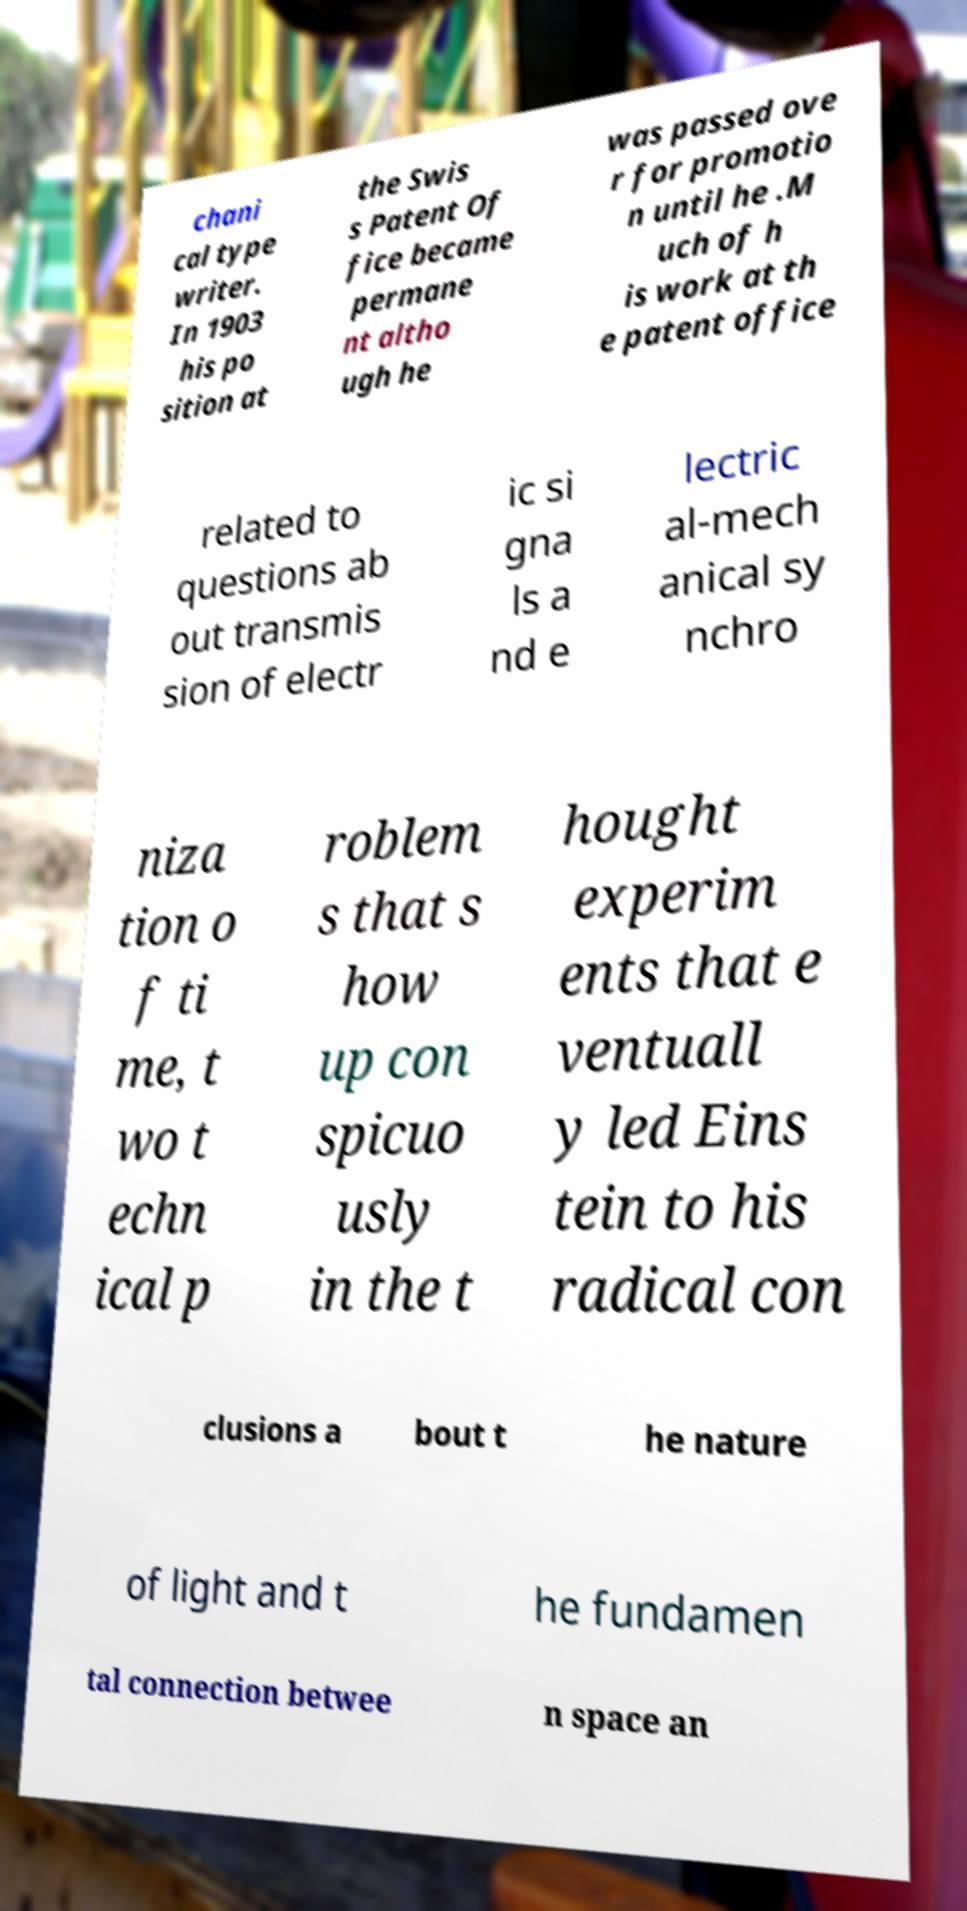Could you assist in decoding the text presented in this image and type it out clearly? chani cal type writer. In 1903 his po sition at the Swis s Patent Of fice became permane nt altho ugh he was passed ove r for promotio n until he .M uch of h is work at th e patent office related to questions ab out transmis sion of electr ic si gna ls a nd e lectric al-mech anical sy nchro niza tion o f ti me, t wo t echn ical p roblem s that s how up con spicuo usly in the t hought experim ents that e ventuall y led Eins tein to his radical con clusions a bout t he nature of light and t he fundamen tal connection betwee n space an 